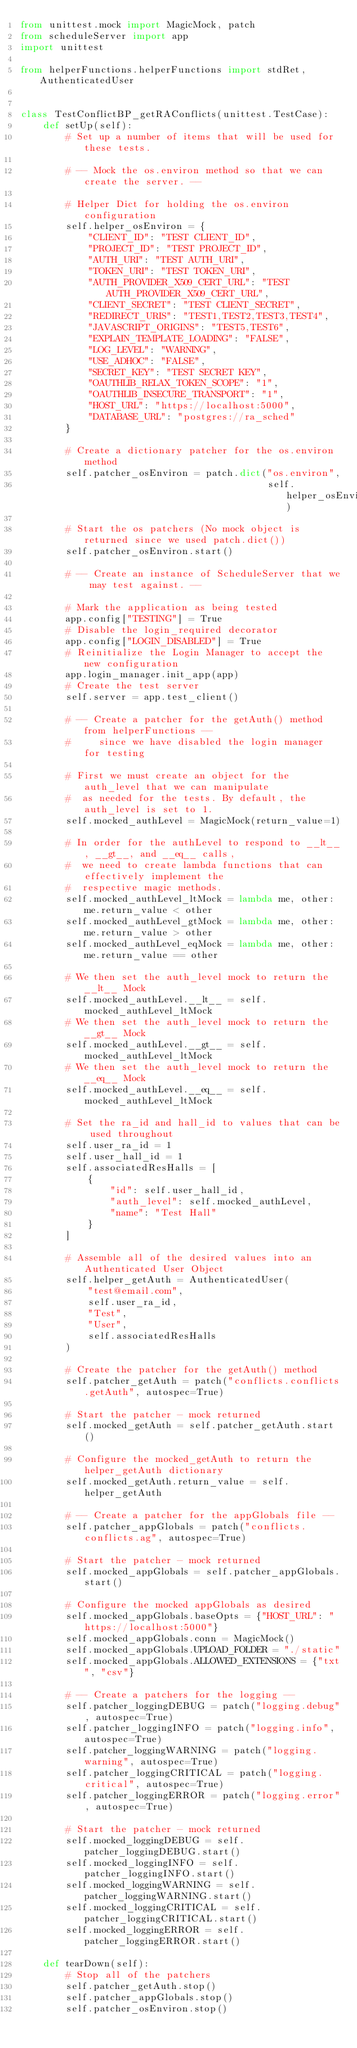Convert code to text. <code><loc_0><loc_0><loc_500><loc_500><_Python_>from unittest.mock import MagicMock, patch
from scheduleServer import app
import unittest

from helperFunctions.helperFunctions import stdRet, AuthenticatedUser


class TestConflictBP_getRAConflicts(unittest.TestCase):
    def setUp(self):
        # Set up a number of items that will be used for these tests.

        # -- Mock the os.environ method so that we can create the server. --

        # Helper Dict for holding the os.environ configuration
        self.helper_osEnviron = {
            "CLIENT_ID": "TEST CLIENT_ID",
            "PROJECT_ID": "TEST PROJECT_ID",
            "AUTH_URI": "TEST AUTH_URI",
            "TOKEN_URI": "TEST TOKEN_URI",
            "AUTH_PROVIDER_X509_CERT_URL": "TEST AUTH_PROVIDER_X509_CERT_URL",
            "CLIENT_SECRET": "TEST CLIENT_SECRET",
            "REDIRECT_URIS": "TEST1,TEST2,TEST3,TEST4",
            "JAVASCRIPT_ORIGINS": "TEST5,TEST6",
            "EXPLAIN_TEMPLATE_LOADING": "FALSE",
            "LOG_LEVEL": "WARNING",
            "USE_ADHOC": "FALSE",
            "SECRET_KEY": "TEST SECRET KEY",
            "OAUTHLIB_RELAX_TOKEN_SCOPE": "1",
            "OAUTHLIB_INSECURE_TRANSPORT": "1",
            "HOST_URL": "https://localhost:5000",
            "DATABASE_URL": "postgres://ra_sched"
        }

        # Create a dictionary patcher for the os.environ method
        self.patcher_osEnviron = patch.dict("os.environ",
                                            self.helper_osEnviron)

        # Start the os patchers (No mock object is returned since we used patch.dict())
        self.patcher_osEnviron.start()

        # -- Create an instance of ScheduleServer that we may test against. --

        # Mark the application as being tested
        app.config["TESTING"] = True
        # Disable the login_required decorator
        app.config["LOGIN_DISABLED"] = True
        # Reinitialize the Login Manager to accept the new configuration
        app.login_manager.init_app(app)
        # Create the test server
        self.server = app.test_client()

        # -- Create a patcher for the getAuth() method from helperFunctions --
        #     since we have disabled the login manager for testing

        # First we must create an object for the auth_level that we can manipulate
        #  as needed for the tests. By default, the auth_level is set to 1.
        self.mocked_authLevel = MagicMock(return_value=1)

        # In order for the authLevel to respond to __lt__, __gt__, and __eq__ calls,
        #  we need to create lambda functions that can effectively implement the
        #  respective magic methods.
        self.mocked_authLevel_ltMock = lambda me, other: me.return_value < other
        self.mocked_authLevel_gtMock = lambda me, other: me.return_value > other
        self.mocked_authLevel_eqMock = lambda me, other: me.return_value == other

        # We then set the auth_level mock to return the __lt__ Mock
        self.mocked_authLevel.__lt__ = self.mocked_authLevel_ltMock
        # We then set the auth_level mock to return the __gt__ Mock
        self.mocked_authLevel.__gt__ = self.mocked_authLevel_ltMock
        # We then set the auth_level mock to return the __eq__ Mock
        self.mocked_authLevel.__eq__ = self.mocked_authLevel_ltMock

        # Set the ra_id and hall_id to values that can be used throughout
        self.user_ra_id = 1
        self.user_hall_id = 1
        self.associatedResHalls = [
            {
                "id": self.user_hall_id,
                "auth_level": self.mocked_authLevel,
                "name": "Test Hall"
            }
        ]

        # Assemble all of the desired values into an Authenticated User Object
        self.helper_getAuth = AuthenticatedUser(
            "test@email.com",
            self.user_ra_id,
            "Test",
            "User",
            self.associatedResHalls
        )

        # Create the patcher for the getAuth() method
        self.patcher_getAuth = patch("conflicts.conflicts.getAuth", autospec=True)

        # Start the patcher - mock returned
        self.mocked_getAuth = self.patcher_getAuth.start()

        # Configure the mocked_getAuth to return the helper_getAuth dictionary
        self.mocked_getAuth.return_value = self.helper_getAuth

        # -- Create a patcher for the appGlobals file --
        self.patcher_appGlobals = patch("conflicts.conflicts.ag", autospec=True)

        # Start the patcher - mock returned
        self.mocked_appGlobals = self.patcher_appGlobals.start()

        # Configure the mocked appGlobals as desired
        self.mocked_appGlobals.baseOpts = {"HOST_URL": "https://localhost:5000"}
        self.mocked_appGlobals.conn = MagicMock()
        self.mocked_appGlobals.UPLOAD_FOLDER = "./static"
        self.mocked_appGlobals.ALLOWED_EXTENSIONS = {"txt", "csv"}

        # -- Create a patchers for the logging --
        self.patcher_loggingDEBUG = patch("logging.debug", autospec=True)
        self.patcher_loggingINFO = patch("logging.info", autospec=True)
        self.patcher_loggingWARNING = patch("logging.warning", autospec=True)
        self.patcher_loggingCRITICAL = patch("logging.critical", autospec=True)
        self.patcher_loggingERROR = patch("logging.error", autospec=True)

        # Start the patcher - mock returned
        self.mocked_loggingDEBUG = self.patcher_loggingDEBUG.start()
        self.mocked_loggingINFO = self.patcher_loggingINFO.start()
        self.mocked_loggingWARNING = self.patcher_loggingWARNING.start()
        self.mocked_loggingCRITICAL = self.patcher_loggingCRITICAL.start()
        self.mocked_loggingERROR = self.patcher_loggingERROR.start()

    def tearDown(self):
        # Stop all of the patchers
        self.patcher_getAuth.stop()
        self.patcher_appGlobals.stop()
        self.patcher_osEnviron.stop()
</code> 